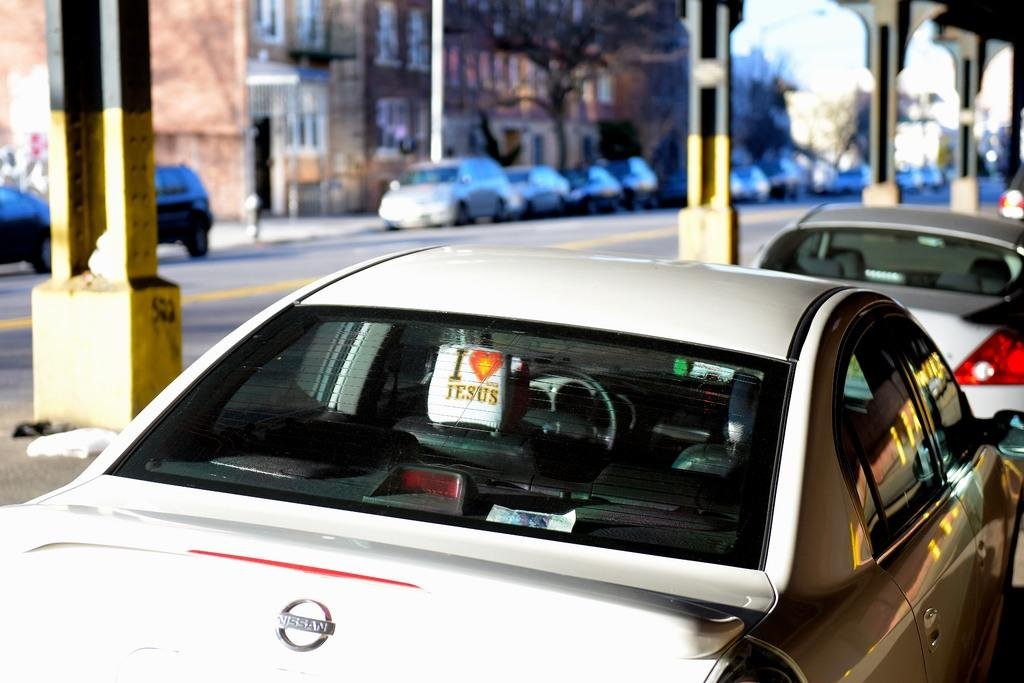What type of vehicles can be seen in the image? There are cars in the image. What structures are present in the center of the image? There are pillars in the center of the image. What can be seen in the background of the image? There are trees and buildings in the background of the image. Can you see the dad giving a kiss to his child in the image? There is no mention of a dad or a child in the image, so it cannot be determined if a kiss is being given. 